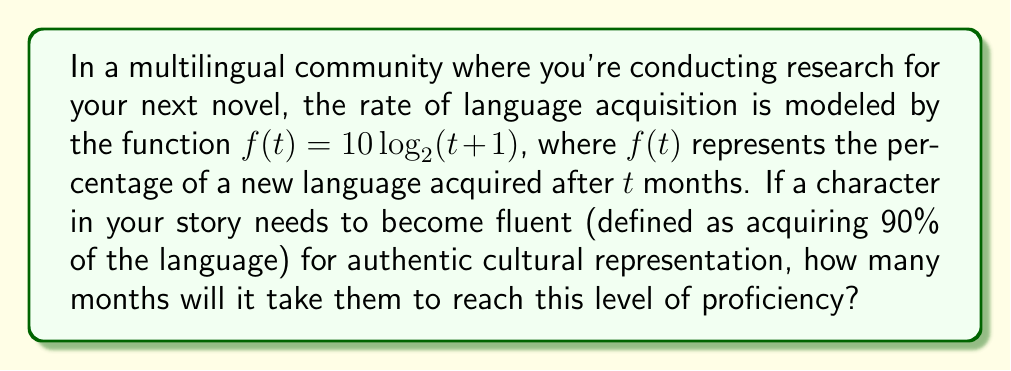Teach me how to tackle this problem. To solve this problem, we need to follow these steps:

1) We're looking for the value of $t$ when $f(t) = 90$. So, we need to solve the equation:

   $90 = 10 \log_2(t + 1)$

2) Divide both sides by 10:

   $9 = \log_2(t + 1)$

3) To solve for $t$, we need to apply the inverse function of $\log_2$, which is $2^x$:

   $2^9 = t + 1$

4) Calculate $2^9$:

   $512 = t + 1$

5) Subtract 1 from both sides:

   $511 = t$

Therefore, it will take 511 months for the character to become fluent in the new language according to this model.
Answer: 511 months 